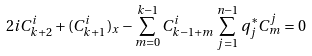<formula> <loc_0><loc_0><loc_500><loc_500>2 i C _ { k + 2 } ^ { i } + ( C ^ { i } _ { k + 1 } ) _ { x } - \sum _ { m = 0 } ^ { k - 1 } C ^ { i } _ { k - 1 + m } \sum _ { j = 1 } ^ { n - 1 } q _ { j } ^ { * } C ^ { j } _ { m } = 0 \\</formula> 